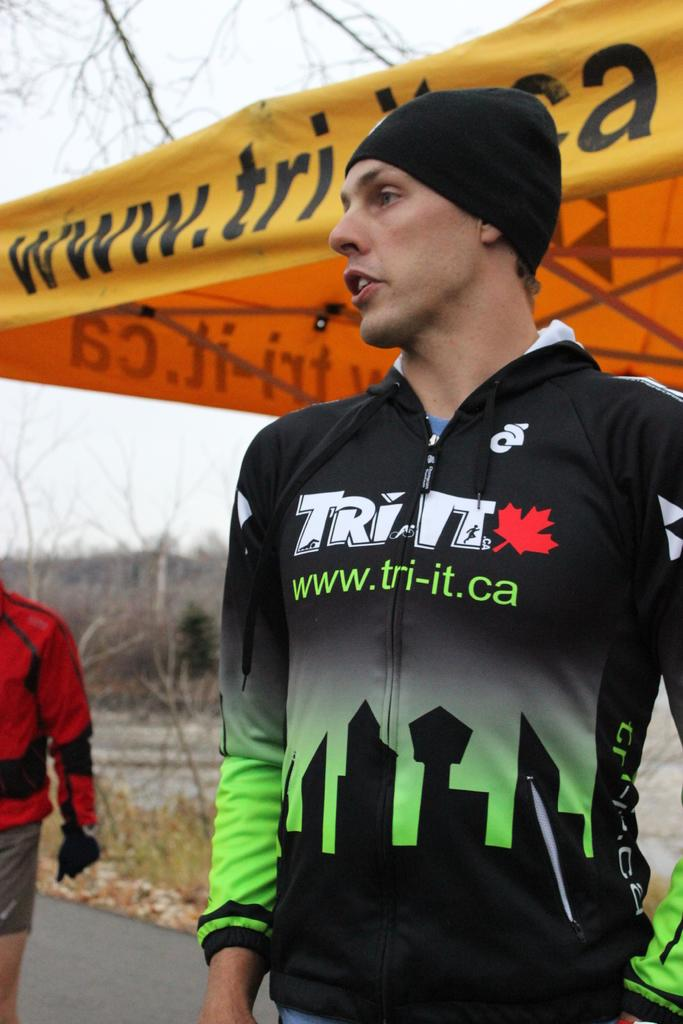<image>
Provide a brief description of the given image. A young man wears a jacket with a tri-it.com web address on it. 